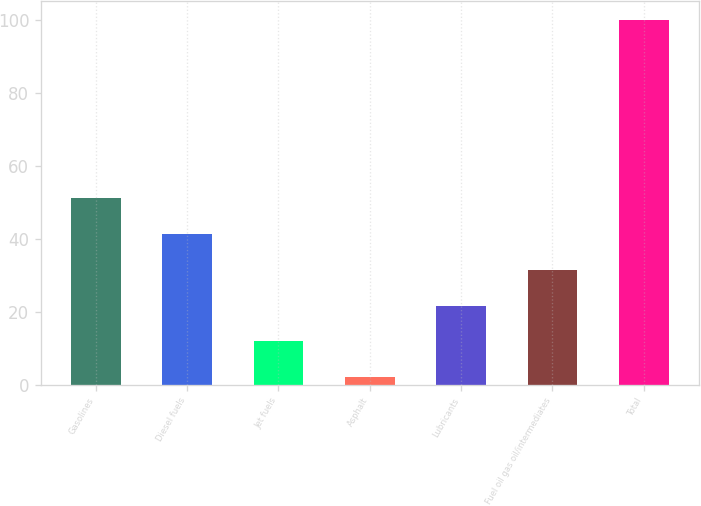Convert chart. <chart><loc_0><loc_0><loc_500><loc_500><bar_chart><fcel>Gasolines<fcel>Diesel fuels<fcel>Jet fuels<fcel>Asphalt<fcel>Lubricants<fcel>Fuel oil gas oil/intermediates<fcel>Total<nl><fcel>51<fcel>41.2<fcel>11.8<fcel>2<fcel>21.6<fcel>31.4<fcel>100<nl></chart> 